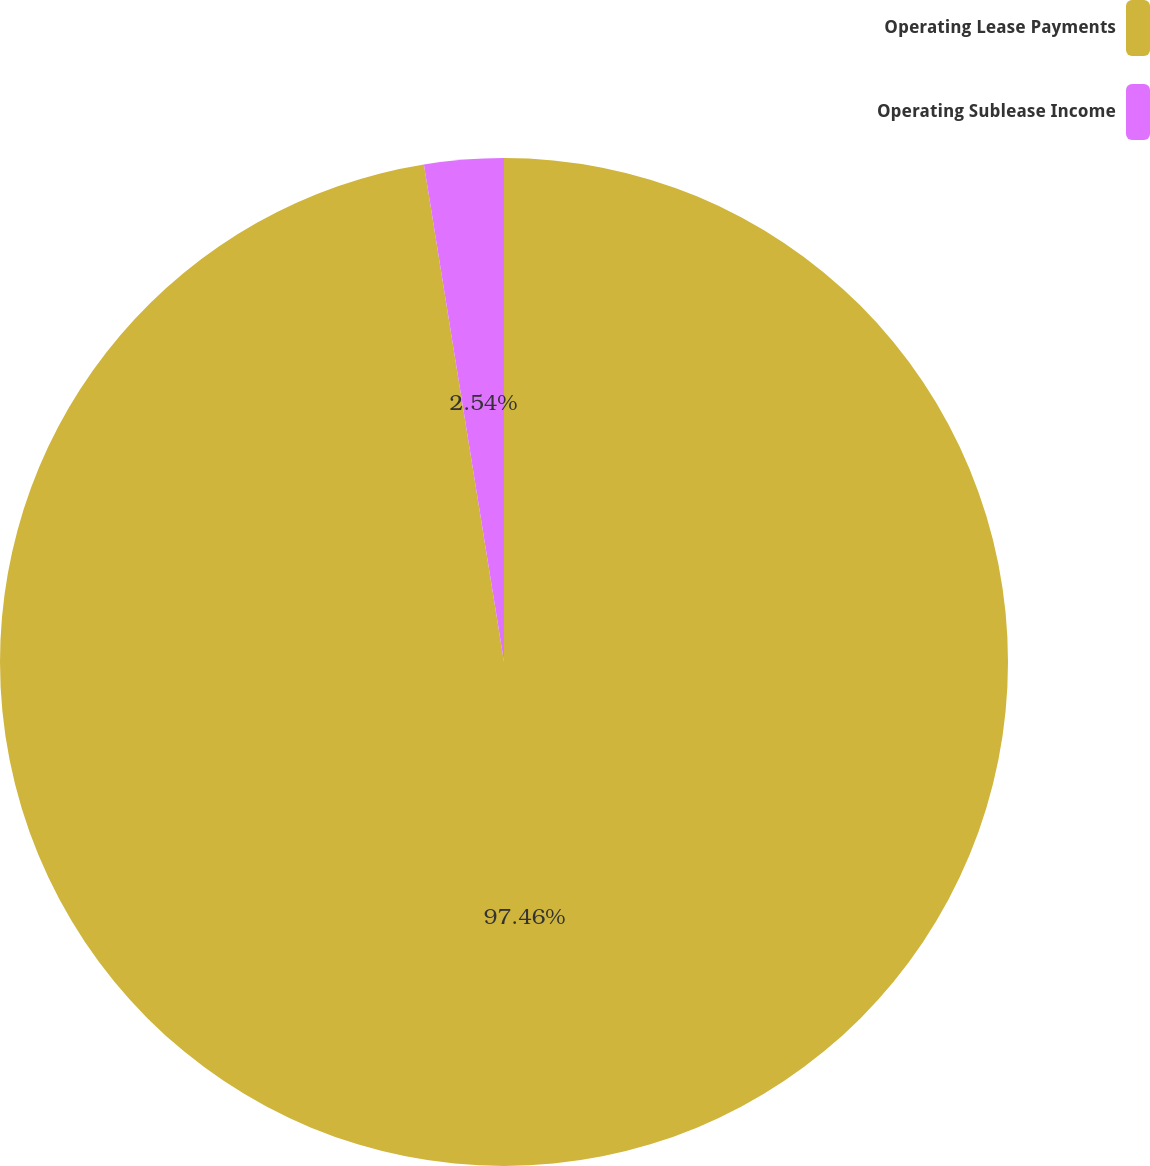Convert chart to OTSL. <chart><loc_0><loc_0><loc_500><loc_500><pie_chart><fcel>Operating Lease Payments<fcel>Operating Sublease Income<nl><fcel>97.46%<fcel>2.54%<nl></chart> 